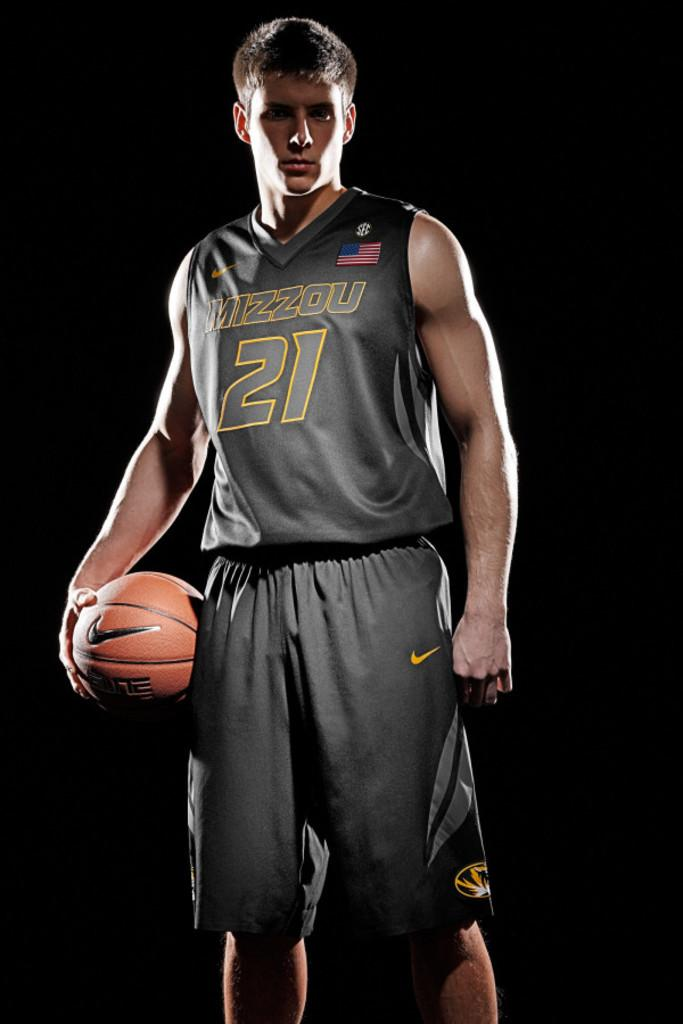Who is present in the image? There is a man in the image. What is the man holding in his hand? The man is holding a ball in his hand. What sense does the man use to detect the trail in the image? There is no trail present in the image, and therefore no sense is required to detect it. 